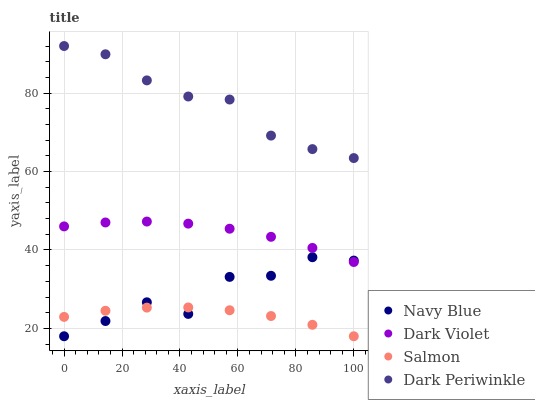Does Salmon have the minimum area under the curve?
Answer yes or no. Yes. Does Dark Periwinkle have the maximum area under the curve?
Answer yes or no. Yes. Does Dark Periwinkle have the minimum area under the curve?
Answer yes or no. No. Does Salmon have the maximum area under the curve?
Answer yes or no. No. Is Salmon the smoothest?
Answer yes or no. Yes. Is Navy Blue the roughest?
Answer yes or no. Yes. Is Dark Periwinkle the smoothest?
Answer yes or no. No. Is Dark Periwinkle the roughest?
Answer yes or no. No. Does Navy Blue have the lowest value?
Answer yes or no. Yes. Does Dark Periwinkle have the lowest value?
Answer yes or no. No. Does Dark Periwinkle have the highest value?
Answer yes or no. Yes. Does Salmon have the highest value?
Answer yes or no. No. Is Salmon less than Dark Periwinkle?
Answer yes or no. Yes. Is Dark Periwinkle greater than Salmon?
Answer yes or no. Yes. Does Salmon intersect Navy Blue?
Answer yes or no. Yes. Is Salmon less than Navy Blue?
Answer yes or no. No. Is Salmon greater than Navy Blue?
Answer yes or no. No. Does Salmon intersect Dark Periwinkle?
Answer yes or no. No. 